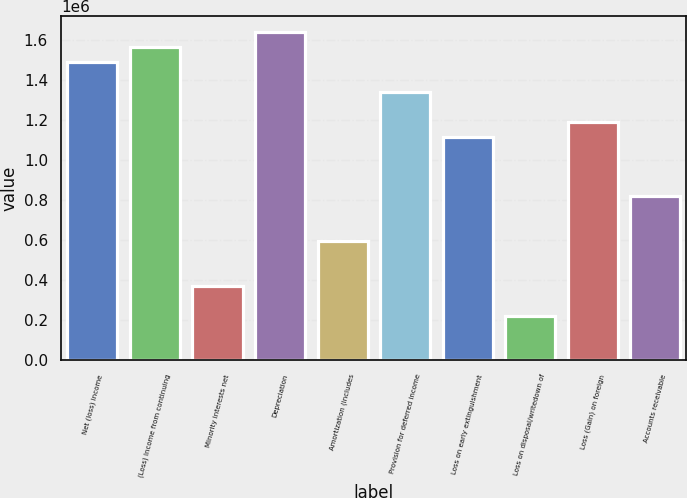Convert chart. <chart><loc_0><loc_0><loc_500><loc_500><bar_chart><fcel>Net (loss) income<fcel>(Loss) Income from continuing<fcel>Minority interests net<fcel>Depreciation<fcel>Amortization (includes<fcel>Provision for deferred income<fcel>Loss on early extinguishment<fcel>Loss on disposal/writedown of<fcel>Loss (Gain) on foreign<fcel>Accounts receivable<nl><fcel>1.48803e+06<fcel>1.56243e+06<fcel>372011<fcel>1.63683e+06<fcel>595214<fcel>1.33922e+06<fcel>1.11602e+06<fcel>223209<fcel>1.19042e+06<fcel>818417<nl></chart> 